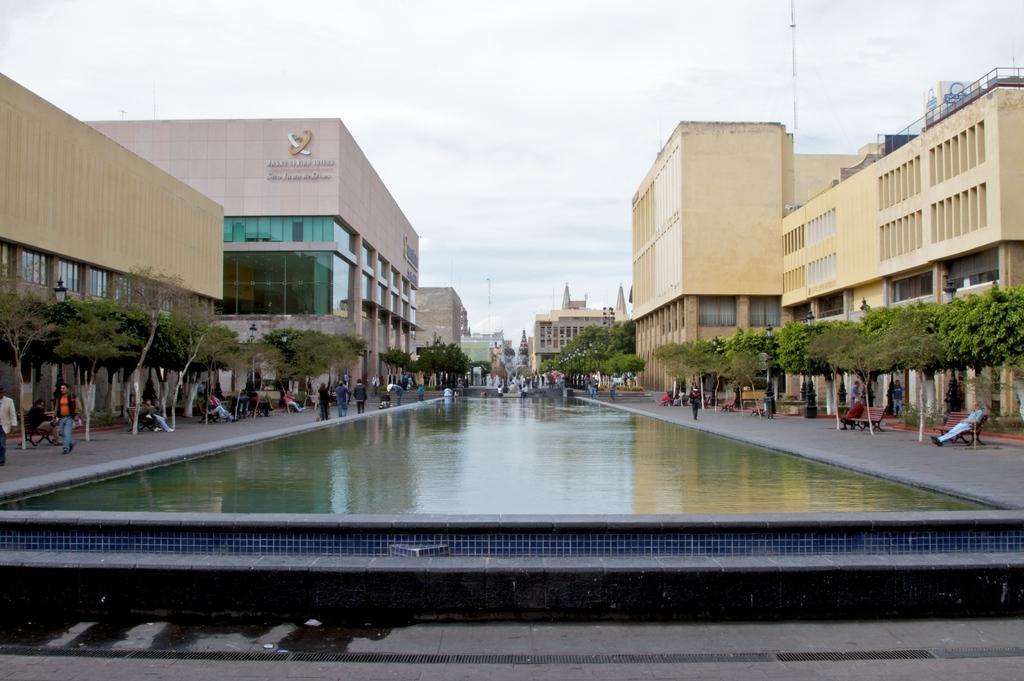Could you give a brief overview of what you see in this image? In this image there is a canal in the middle. There are buildings on either side of the canal. On the floor there are few people walking on it. Beside them there are trees on either side of the footpath. At the top there is the sky. 